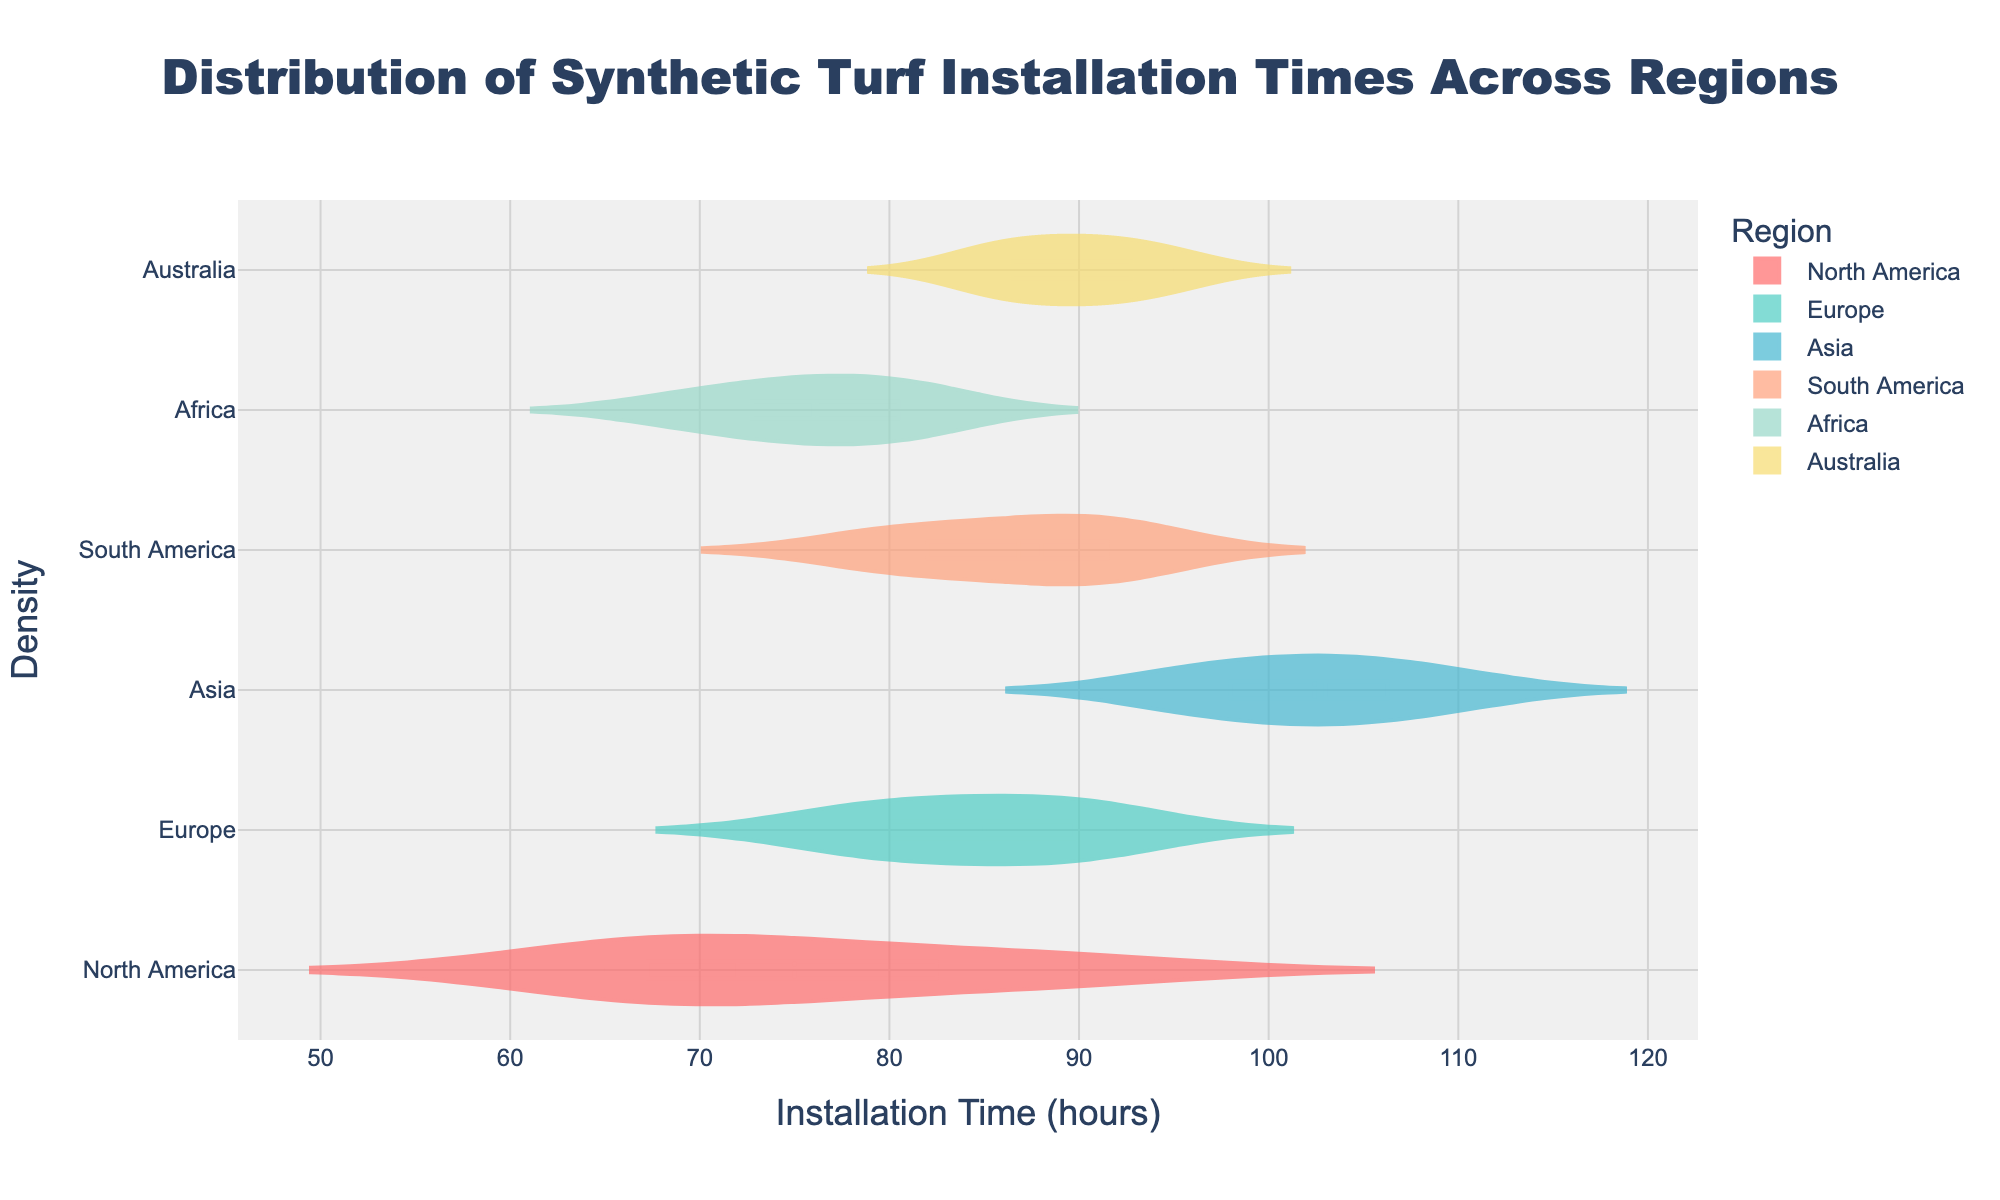What is the average installation time for North America? Identify the North American installation times (72, 80, 65, 90, 68), sum them (72 + 80 + 65 + 90 + 68 = 375) and divide by 5 (375 / 5 = 75).
Answer: 75 hours Which region has the longest installation time? Compare the maximum installation times of all regions: North America (90), Europe (92), Asia (110), South America (93), Africa (82), Australia (95) and find the highest value, which is in Asia.
Answer: Asia Which region has the most variable installation times? Examine the spread and box size in the violins. The region with the widest range from minimum to maximum and the most spread out points indicates the highest variability, which appears to be Asia.
Answer: Asia How does the median installation time in Europe compare to that in Africa? Determine the median line in the violin plot for Europe and Africa. Europe's median is around 85, Africa's is around 76; 85 - 76 = 9 hours higher in Europe.
Answer: Europe is 9 hours higher What is the shape of the distribution for South America like? Look at the violin plot for South America: it is relatively symmetrical and moderately spread, suggesting a generally normal distribution.
Answer: Symmetrical and moderately spread Which region has the smallest range in installation times? Check the distance between the minimum and maximum values for each region. Africa has the smallest range (69 to 82).
Answer: Africa Which region has the highest median installation time? Identify the median line across all violins. Asia has the highest median time, around 100 hours.
Answer: Asia Is there any overlap in the installation time ranges for Europe and North America? Compare the ranges shown by the violins for Europe (77 to 92) and North America (65 to 90). Both ranges overlap in the interval from 77 to 90 hours.
Answer: Yes 